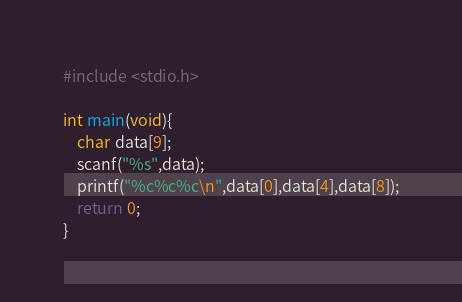Convert code to text. <code><loc_0><loc_0><loc_500><loc_500><_C_>#include <stdio.h>

int main(void){
    char data[9];
    scanf("%s",data);
    printf("%c%c%c\n",data[0],data[4],data[8]);
    return 0;
}</code> 